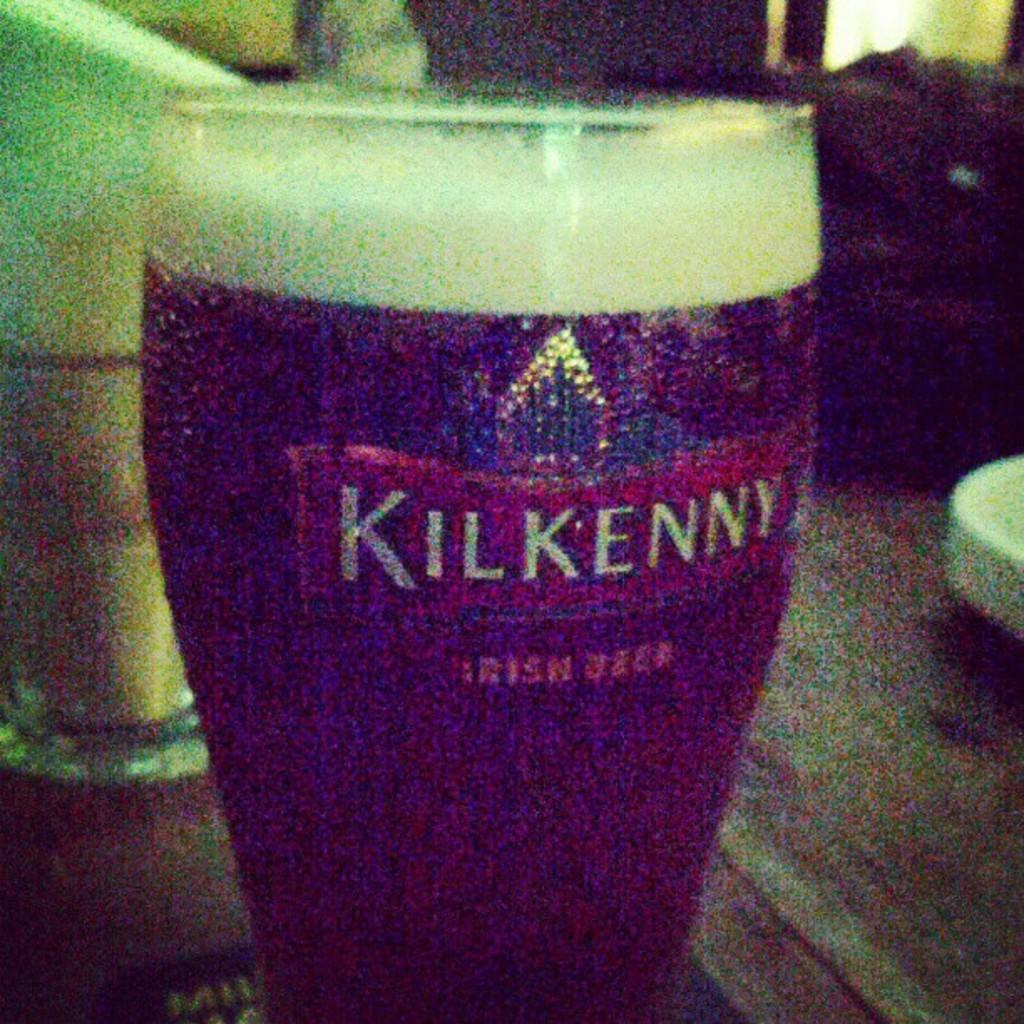<image>
Summarize the visual content of the image. The drink in the glass is called Irish Beer 